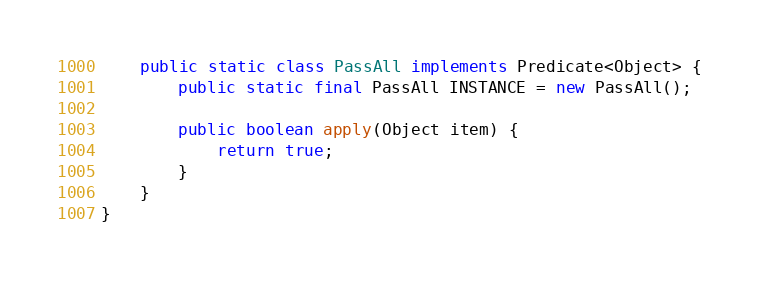<code> <loc_0><loc_0><loc_500><loc_500><_Java_>
    public static class PassAll implements Predicate<Object> {
        public static final PassAll INSTANCE = new PassAll();

        public boolean apply(Object item) {
            return true;
        }
    }
}
</code> 